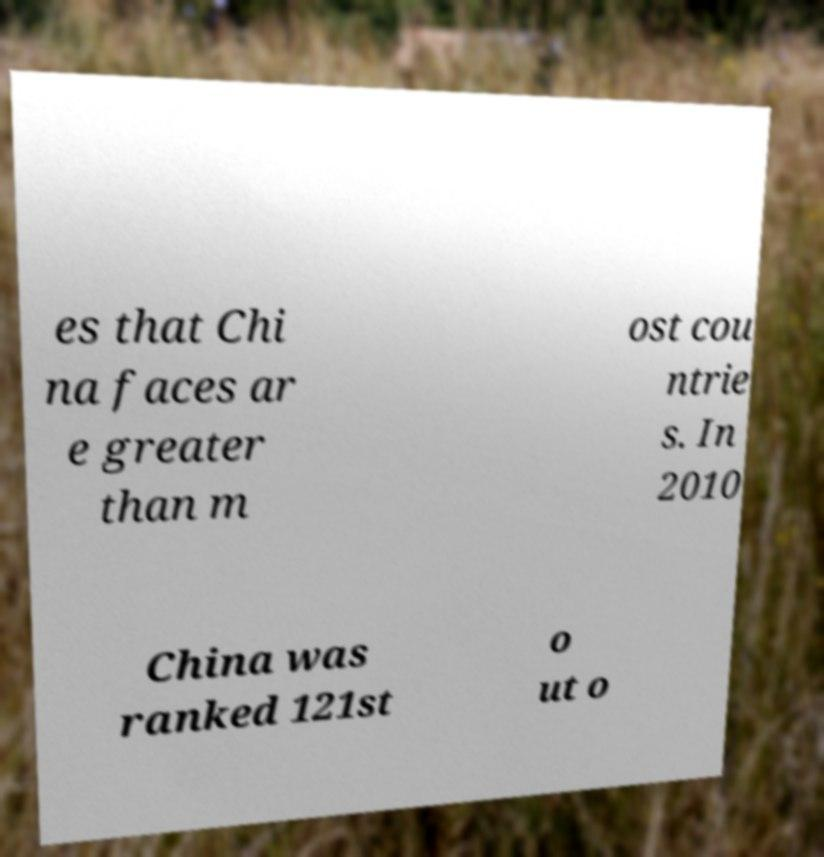Could you assist in decoding the text presented in this image and type it out clearly? es that Chi na faces ar e greater than m ost cou ntrie s. In 2010 China was ranked 121st o ut o 